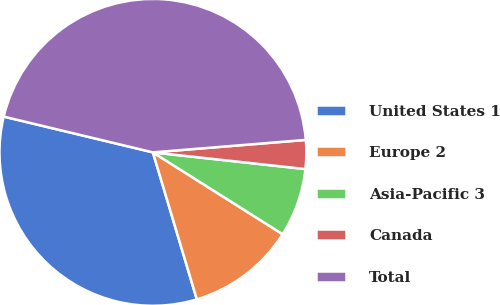Convert chart. <chart><loc_0><loc_0><loc_500><loc_500><pie_chart><fcel>United States 1<fcel>Europe 2<fcel>Asia-Pacific 3<fcel>Canada<fcel>Total<nl><fcel>33.37%<fcel>11.42%<fcel>7.22%<fcel>3.03%<fcel>44.96%<nl></chart> 